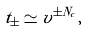Convert formula to latex. <formula><loc_0><loc_0><loc_500><loc_500>t _ { \pm } \simeq v ^ { \pm N _ { c } } ,</formula> 